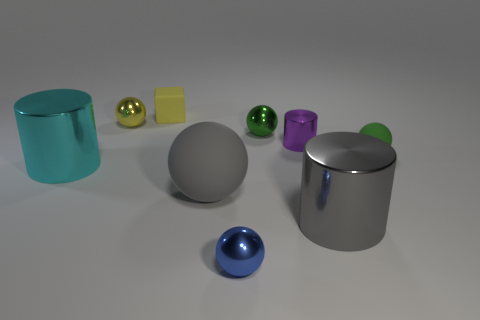Subtract all purple blocks. Subtract all red cylinders. How many blocks are left? 1 Subtract all balls. How many objects are left? 4 Subtract 0 purple cubes. How many objects are left? 9 Subtract all green metal spheres. Subtract all big gray objects. How many objects are left? 6 Add 1 green things. How many green things are left? 3 Add 8 big gray rubber things. How many big gray rubber things exist? 9 